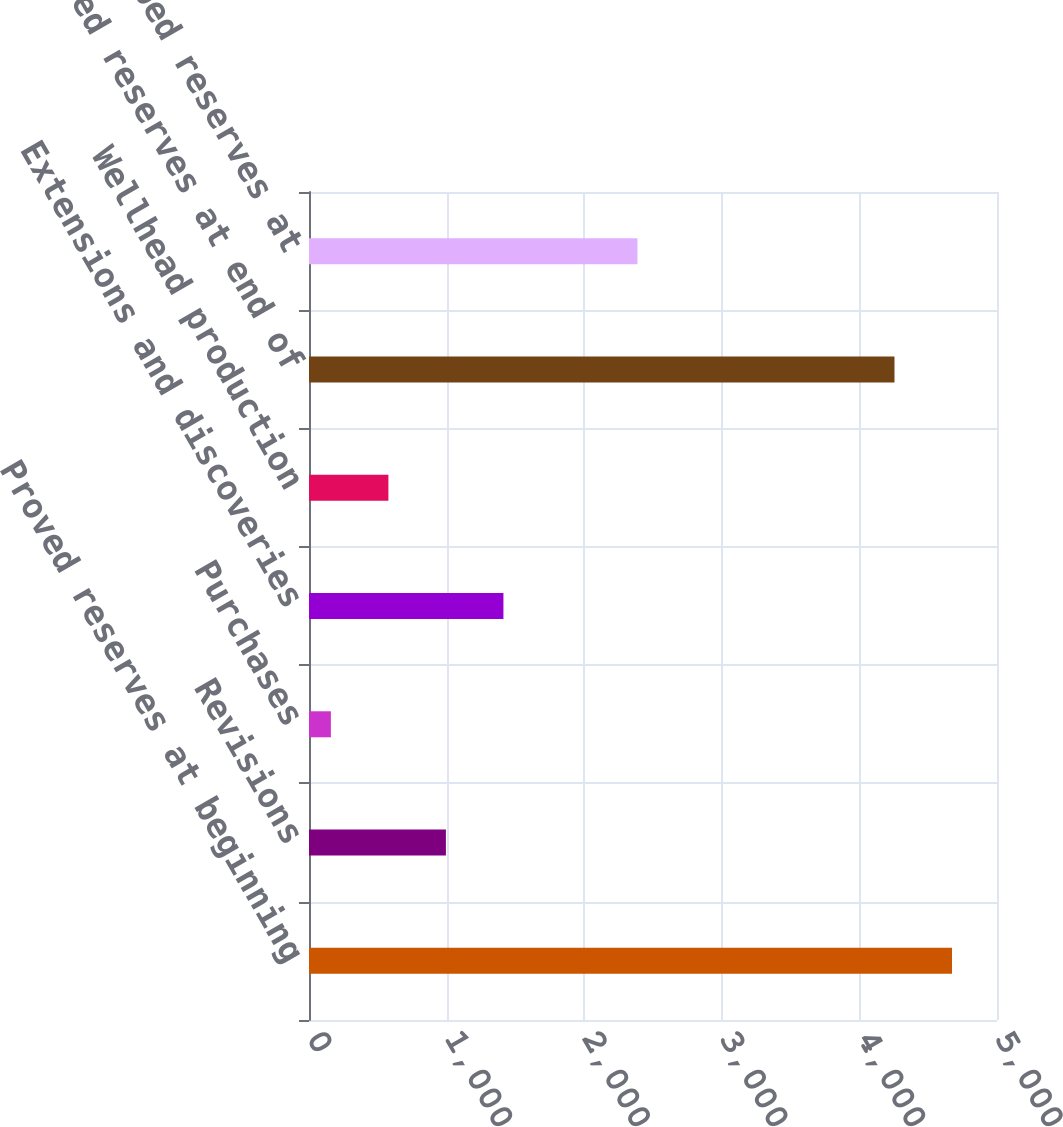Convert chart. <chart><loc_0><loc_0><loc_500><loc_500><bar_chart><fcel>Proved reserves at beginning<fcel>Revisions<fcel>Purchases<fcel>Extensions and discoveries<fcel>Wellhead production<fcel>Proved reserves at end of<fcel>Proved developed reserves at<nl><fcel>4673<fcel>995<fcel>159<fcel>1413<fcel>577<fcel>4255<fcel>2387<nl></chart> 